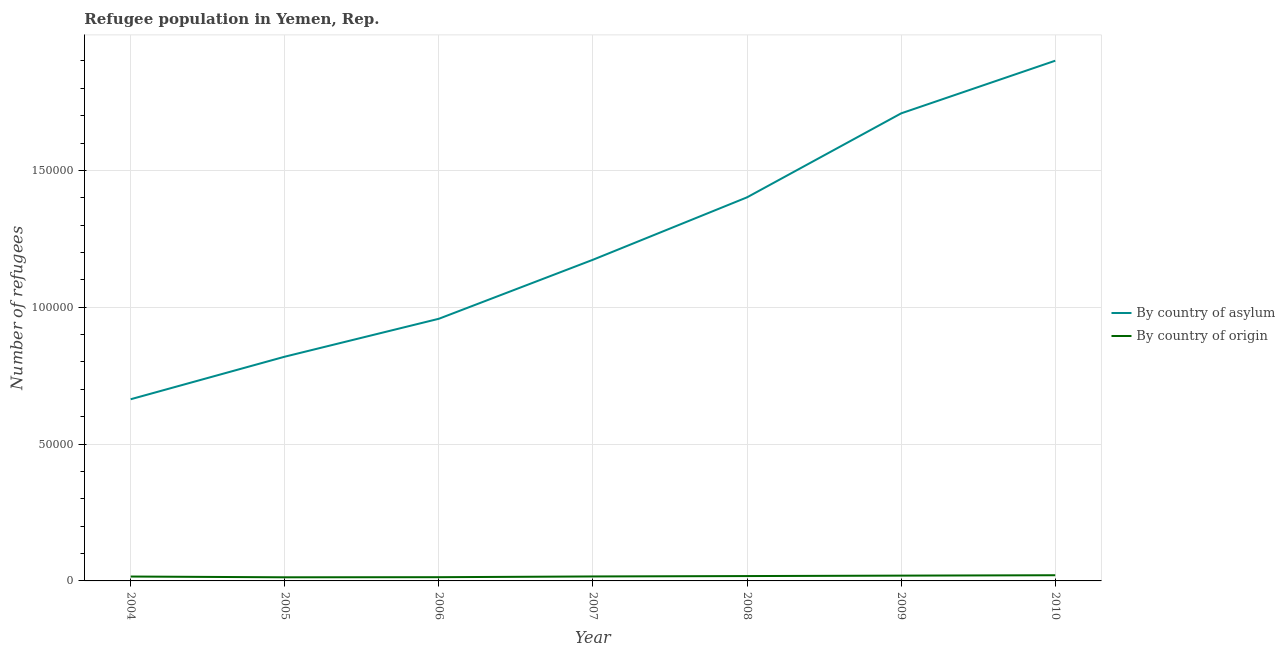Does the line corresponding to number of refugees by country of origin intersect with the line corresponding to number of refugees by country of asylum?
Make the answer very short. No. What is the number of refugees by country of origin in 2006?
Keep it short and to the point. 1362. Across all years, what is the maximum number of refugees by country of origin?
Keep it short and to the point. 2076. Across all years, what is the minimum number of refugees by country of asylum?
Your response must be concise. 6.64e+04. What is the total number of refugees by country of origin in the graph?
Ensure brevity in your answer.  1.17e+04. What is the difference between the number of refugees by country of asylum in 2004 and that in 2005?
Your answer should be very brief. -1.56e+04. What is the difference between the number of refugees by country of asylum in 2004 and the number of refugees by country of origin in 2007?
Offer a very short reply. 6.48e+04. What is the average number of refugees by country of asylum per year?
Your response must be concise. 1.23e+05. In the year 2005, what is the difference between the number of refugees by country of origin and number of refugees by country of asylum?
Give a very brief answer. -8.06e+04. What is the ratio of the number of refugees by country of origin in 2007 to that in 2010?
Give a very brief answer. 0.79. What is the difference between the highest and the second highest number of refugees by country of origin?
Offer a very short reply. 142. What is the difference between the highest and the lowest number of refugees by country of asylum?
Your answer should be compact. 1.24e+05. In how many years, is the number of refugees by country of origin greater than the average number of refugees by country of origin taken over all years?
Provide a succinct answer. 3. Is the sum of the number of refugees by country of asylum in 2008 and 2009 greater than the maximum number of refugees by country of origin across all years?
Provide a short and direct response. Yes. Is the number of refugees by country of asylum strictly greater than the number of refugees by country of origin over the years?
Your response must be concise. Yes. How many years are there in the graph?
Provide a short and direct response. 7. What is the difference between two consecutive major ticks on the Y-axis?
Offer a very short reply. 5.00e+04. Are the values on the major ticks of Y-axis written in scientific E-notation?
Offer a terse response. No. Does the graph contain grids?
Make the answer very short. Yes. How are the legend labels stacked?
Offer a terse response. Vertical. What is the title of the graph?
Provide a succinct answer. Refugee population in Yemen, Rep. Does "Foreign liabilities" appear as one of the legend labels in the graph?
Give a very brief answer. No. What is the label or title of the X-axis?
Ensure brevity in your answer.  Year. What is the label or title of the Y-axis?
Offer a terse response. Number of refugees. What is the Number of refugees of By country of asylum in 2004?
Provide a short and direct response. 6.64e+04. What is the Number of refugees of By country of origin in 2004?
Provide a short and direct response. 1606. What is the Number of refugees in By country of asylum in 2005?
Make the answer very short. 8.19e+04. What is the Number of refugees of By country of origin in 2005?
Ensure brevity in your answer.  1325. What is the Number of refugees in By country of asylum in 2006?
Offer a terse response. 9.58e+04. What is the Number of refugees of By country of origin in 2006?
Provide a succinct answer. 1362. What is the Number of refugees in By country of asylum in 2007?
Provide a succinct answer. 1.17e+05. What is the Number of refugees of By country of origin in 2007?
Your response must be concise. 1632. What is the Number of refugees of By country of asylum in 2008?
Your response must be concise. 1.40e+05. What is the Number of refugees in By country of origin in 2008?
Your response must be concise. 1777. What is the Number of refugees of By country of asylum in 2009?
Your answer should be very brief. 1.71e+05. What is the Number of refugees in By country of origin in 2009?
Your response must be concise. 1934. What is the Number of refugees of By country of asylum in 2010?
Your answer should be very brief. 1.90e+05. What is the Number of refugees of By country of origin in 2010?
Your response must be concise. 2076. Across all years, what is the maximum Number of refugees in By country of asylum?
Keep it short and to the point. 1.90e+05. Across all years, what is the maximum Number of refugees in By country of origin?
Offer a terse response. 2076. Across all years, what is the minimum Number of refugees of By country of asylum?
Your response must be concise. 6.64e+04. Across all years, what is the minimum Number of refugees in By country of origin?
Provide a short and direct response. 1325. What is the total Number of refugees of By country of asylum in the graph?
Make the answer very short. 8.63e+05. What is the total Number of refugees of By country of origin in the graph?
Your answer should be compact. 1.17e+04. What is the difference between the Number of refugees of By country of asylum in 2004 and that in 2005?
Ensure brevity in your answer.  -1.56e+04. What is the difference between the Number of refugees in By country of origin in 2004 and that in 2005?
Your response must be concise. 281. What is the difference between the Number of refugees in By country of asylum in 2004 and that in 2006?
Make the answer very short. -2.94e+04. What is the difference between the Number of refugees of By country of origin in 2004 and that in 2006?
Provide a succinct answer. 244. What is the difference between the Number of refugees of By country of asylum in 2004 and that in 2007?
Keep it short and to the point. -5.10e+04. What is the difference between the Number of refugees in By country of origin in 2004 and that in 2007?
Provide a short and direct response. -26. What is the difference between the Number of refugees in By country of asylum in 2004 and that in 2008?
Your response must be concise. -7.38e+04. What is the difference between the Number of refugees in By country of origin in 2004 and that in 2008?
Your response must be concise. -171. What is the difference between the Number of refugees of By country of asylum in 2004 and that in 2009?
Ensure brevity in your answer.  -1.04e+05. What is the difference between the Number of refugees of By country of origin in 2004 and that in 2009?
Provide a short and direct response. -328. What is the difference between the Number of refugees of By country of asylum in 2004 and that in 2010?
Keep it short and to the point. -1.24e+05. What is the difference between the Number of refugees of By country of origin in 2004 and that in 2010?
Offer a very short reply. -470. What is the difference between the Number of refugees in By country of asylum in 2005 and that in 2006?
Give a very brief answer. -1.39e+04. What is the difference between the Number of refugees in By country of origin in 2005 and that in 2006?
Give a very brief answer. -37. What is the difference between the Number of refugees of By country of asylum in 2005 and that in 2007?
Your answer should be very brief. -3.54e+04. What is the difference between the Number of refugees in By country of origin in 2005 and that in 2007?
Provide a succinct answer. -307. What is the difference between the Number of refugees in By country of asylum in 2005 and that in 2008?
Your response must be concise. -5.82e+04. What is the difference between the Number of refugees in By country of origin in 2005 and that in 2008?
Keep it short and to the point. -452. What is the difference between the Number of refugees of By country of asylum in 2005 and that in 2009?
Give a very brief answer. -8.89e+04. What is the difference between the Number of refugees in By country of origin in 2005 and that in 2009?
Make the answer very short. -609. What is the difference between the Number of refugees of By country of asylum in 2005 and that in 2010?
Your answer should be compact. -1.08e+05. What is the difference between the Number of refugees of By country of origin in 2005 and that in 2010?
Your answer should be compact. -751. What is the difference between the Number of refugees in By country of asylum in 2006 and that in 2007?
Offer a very short reply. -2.16e+04. What is the difference between the Number of refugees of By country of origin in 2006 and that in 2007?
Provide a short and direct response. -270. What is the difference between the Number of refugees in By country of asylum in 2006 and that in 2008?
Keep it short and to the point. -4.44e+04. What is the difference between the Number of refugees of By country of origin in 2006 and that in 2008?
Offer a terse response. -415. What is the difference between the Number of refugees of By country of asylum in 2006 and that in 2009?
Offer a very short reply. -7.51e+04. What is the difference between the Number of refugees of By country of origin in 2006 and that in 2009?
Your answer should be very brief. -572. What is the difference between the Number of refugees in By country of asylum in 2006 and that in 2010?
Provide a succinct answer. -9.43e+04. What is the difference between the Number of refugees of By country of origin in 2006 and that in 2010?
Your response must be concise. -714. What is the difference between the Number of refugees of By country of asylum in 2007 and that in 2008?
Make the answer very short. -2.28e+04. What is the difference between the Number of refugees of By country of origin in 2007 and that in 2008?
Make the answer very short. -145. What is the difference between the Number of refugees in By country of asylum in 2007 and that in 2009?
Your answer should be compact. -5.35e+04. What is the difference between the Number of refugees of By country of origin in 2007 and that in 2009?
Offer a very short reply. -302. What is the difference between the Number of refugees of By country of asylum in 2007 and that in 2010?
Your response must be concise. -7.27e+04. What is the difference between the Number of refugees in By country of origin in 2007 and that in 2010?
Your answer should be compact. -444. What is the difference between the Number of refugees of By country of asylum in 2008 and that in 2009?
Offer a terse response. -3.07e+04. What is the difference between the Number of refugees in By country of origin in 2008 and that in 2009?
Provide a succinct answer. -157. What is the difference between the Number of refugees of By country of asylum in 2008 and that in 2010?
Make the answer very short. -4.99e+04. What is the difference between the Number of refugees of By country of origin in 2008 and that in 2010?
Keep it short and to the point. -299. What is the difference between the Number of refugees in By country of asylum in 2009 and that in 2010?
Your answer should be compact. -1.92e+04. What is the difference between the Number of refugees of By country of origin in 2009 and that in 2010?
Your answer should be compact. -142. What is the difference between the Number of refugees in By country of asylum in 2004 and the Number of refugees in By country of origin in 2005?
Ensure brevity in your answer.  6.51e+04. What is the difference between the Number of refugees of By country of asylum in 2004 and the Number of refugees of By country of origin in 2006?
Offer a very short reply. 6.50e+04. What is the difference between the Number of refugees of By country of asylum in 2004 and the Number of refugees of By country of origin in 2007?
Make the answer very short. 6.48e+04. What is the difference between the Number of refugees of By country of asylum in 2004 and the Number of refugees of By country of origin in 2008?
Provide a succinct answer. 6.46e+04. What is the difference between the Number of refugees in By country of asylum in 2004 and the Number of refugees in By country of origin in 2009?
Your answer should be compact. 6.44e+04. What is the difference between the Number of refugees in By country of asylum in 2004 and the Number of refugees in By country of origin in 2010?
Provide a short and direct response. 6.43e+04. What is the difference between the Number of refugees in By country of asylum in 2005 and the Number of refugees in By country of origin in 2006?
Give a very brief answer. 8.06e+04. What is the difference between the Number of refugees in By country of asylum in 2005 and the Number of refugees in By country of origin in 2007?
Ensure brevity in your answer.  8.03e+04. What is the difference between the Number of refugees in By country of asylum in 2005 and the Number of refugees in By country of origin in 2008?
Your answer should be very brief. 8.02e+04. What is the difference between the Number of refugees in By country of asylum in 2005 and the Number of refugees in By country of origin in 2009?
Make the answer very short. 8.00e+04. What is the difference between the Number of refugees in By country of asylum in 2005 and the Number of refugees in By country of origin in 2010?
Make the answer very short. 7.99e+04. What is the difference between the Number of refugees of By country of asylum in 2006 and the Number of refugees of By country of origin in 2007?
Keep it short and to the point. 9.42e+04. What is the difference between the Number of refugees of By country of asylum in 2006 and the Number of refugees of By country of origin in 2008?
Keep it short and to the point. 9.40e+04. What is the difference between the Number of refugees in By country of asylum in 2006 and the Number of refugees in By country of origin in 2009?
Your answer should be very brief. 9.39e+04. What is the difference between the Number of refugees in By country of asylum in 2006 and the Number of refugees in By country of origin in 2010?
Give a very brief answer. 9.37e+04. What is the difference between the Number of refugees of By country of asylum in 2007 and the Number of refugees of By country of origin in 2008?
Keep it short and to the point. 1.16e+05. What is the difference between the Number of refugees of By country of asylum in 2007 and the Number of refugees of By country of origin in 2009?
Your answer should be compact. 1.15e+05. What is the difference between the Number of refugees of By country of asylum in 2007 and the Number of refugees of By country of origin in 2010?
Keep it short and to the point. 1.15e+05. What is the difference between the Number of refugees of By country of asylum in 2008 and the Number of refugees of By country of origin in 2009?
Your response must be concise. 1.38e+05. What is the difference between the Number of refugees in By country of asylum in 2008 and the Number of refugees in By country of origin in 2010?
Ensure brevity in your answer.  1.38e+05. What is the difference between the Number of refugees of By country of asylum in 2009 and the Number of refugees of By country of origin in 2010?
Your answer should be compact. 1.69e+05. What is the average Number of refugees of By country of asylum per year?
Your response must be concise. 1.23e+05. What is the average Number of refugees of By country of origin per year?
Keep it short and to the point. 1673.14. In the year 2004, what is the difference between the Number of refugees of By country of asylum and Number of refugees of By country of origin?
Offer a terse response. 6.48e+04. In the year 2005, what is the difference between the Number of refugees in By country of asylum and Number of refugees in By country of origin?
Provide a succinct answer. 8.06e+04. In the year 2006, what is the difference between the Number of refugees of By country of asylum and Number of refugees of By country of origin?
Ensure brevity in your answer.  9.44e+04. In the year 2007, what is the difference between the Number of refugees of By country of asylum and Number of refugees of By country of origin?
Your answer should be very brief. 1.16e+05. In the year 2008, what is the difference between the Number of refugees of By country of asylum and Number of refugees of By country of origin?
Your answer should be compact. 1.38e+05. In the year 2009, what is the difference between the Number of refugees of By country of asylum and Number of refugees of By country of origin?
Provide a short and direct response. 1.69e+05. In the year 2010, what is the difference between the Number of refugees in By country of asylum and Number of refugees in By country of origin?
Your answer should be very brief. 1.88e+05. What is the ratio of the Number of refugees in By country of asylum in 2004 to that in 2005?
Offer a very short reply. 0.81. What is the ratio of the Number of refugees in By country of origin in 2004 to that in 2005?
Your answer should be compact. 1.21. What is the ratio of the Number of refugees in By country of asylum in 2004 to that in 2006?
Provide a succinct answer. 0.69. What is the ratio of the Number of refugees in By country of origin in 2004 to that in 2006?
Offer a very short reply. 1.18. What is the ratio of the Number of refugees in By country of asylum in 2004 to that in 2007?
Provide a short and direct response. 0.57. What is the ratio of the Number of refugees of By country of origin in 2004 to that in 2007?
Give a very brief answer. 0.98. What is the ratio of the Number of refugees in By country of asylum in 2004 to that in 2008?
Provide a succinct answer. 0.47. What is the ratio of the Number of refugees of By country of origin in 2004 to that in 2008?
Offer a very short reply. 0.9. What is the ratio of the Number of refugees in By country of asylum in 2004 to that in 2009?
Provide a short and direct response. 0.39. What is the ratio of the Number of refugees of By country of origin in 2004 to that in 2009?
Ensure brevity in your answer.  0.83. What is the ratio of the Number of refugees in By country of asylum in 2004 to that in 2010?
Keep it short and to the point. 0.35. What is the ratio of the Number of refugees in By country of origin in 2004 to that in 2010?
Keep it short and to the point. 0.77. What is the ratio of the Number of refugees of By country of asylum in 2005 to that in 2006?
Offer a terse response. 0.86. What is the ratio of the Number of refugees in By country of origin in 2005 to that in 2006?
Offer a terse response. 0.97. What is the ratio of the Number of refugees in By country of asylum in 2005 to that in 2007?
Provide a succinct answer. 0.7. What is the ratio of the Number of refugees in By country of origin in 2005 to that in 2007?
Keep it short and to the point. 0.81. What is the ratio of the Number of refugees in By country of asylum in 2005 to that in 2008?
Your response must be concise. 0.58. What is the ratio of the Number of refugees in By country of origin in 2005 to that in 2008?
Keep it short and to the point. 0.75. What is the ratio of the Number of refugees in By country of asylum in 2005 to that in 2009?
Provide a succinct answer. 0.48. What is the ratio of the Number of refugees in By country of origin in 2005 to that in 2009?
Give a very brief answer. 0.69. What is the ratio of the Number of refugees of By country of asylum in 2005 to that in 2010?
Provide a succinct answer. 0.43. What is the ratio of the Number of refugees of By country of origin in 2005 to that in 2010?
Offer a terse response. 0.64. What is the ratio of the Number of refugees in By country of asylum in 2006 to that in 2007?
Provide a succinct answer. 0.82. What is the ratio of the Number of refugees in By country of origin in 2006 to that in 2007?
Provide a succinct answer. 0.83. What is the ratio of the Number of refugees of By country of asylum in 2006 to that in 2008?
Ensure brevity in your answer.  0.68. What is the ratio of the Number of refugees of By country of origin in 2006 to that in 2008?
Ensure brevity in your answer.  0.77. What is the ratio of the Number of refugees in By country of asylum in 2006 to that in 2009?
Offer a terse response. 0.56. What is the ratio of the Number of refugees in By country of origin in 2006 to that in 2009?
Give a very brief answer. 0.7. What is the ratio of the Number of refugees of By country of asylum in 2006 to that in 2010?
Provide a succinct answer. 0.5. What is the ratio of the Number of refugees in By country of origin in 2006 to that in 2010?
Provide a succinct answer. 0.66. What is the ratio of the Number of refugees of By country of asylum in 2007 to that in 2008?
Give a very brief answer. 0.84. What is the ratio of the Number of refugees of By country of origin in 2007 to that in 2008?
Your answer should be compact. 0.92. What is the ratio of the Number of refugees in By country of asylum in 2007 to that in 2009?
Your answer should be very brief. 0.69. What is the ratio of the Number of refugees in By country of origin in 2007 to that in 2009?
Offer a terse response. 0.84. What is the ratio of the Number of refugees of By country of asylum in 2007 to that in 2010?
Provide a succinct answer. 0.62. What is the ratio of the Number of refugees in By country of origin in 2007 to that in 2010?
Keep it short and to the point. 0.79. What is the ratio of the Number of refugees of By country of asylum in 2008 to that in 2009?
Keep it short and to the point. 0.82. What is the ratio of the Number of refugees of By country of origin in 2008 to that in 2009?
Your response must be concise. 0.92. What is the ratio of the Number of refugees of By country of asylum in 2008 to that in 2010?
Offer a terse response. 0.74. What is the ratio of the Number of refugees of By country of origin in 2008 to that in 2010?
Provide a short and direct response. 0.86. What is the ratio of the Number of refugees in By country of asylum in 2009 to that in 2010?
Provide a short and direct response. 0.9. What is the ratio of the Number of refugees of By country of origin in 2009 to that in 2010?
Keep it short and to the point. 0.93. What is the difference between the highest and the second highest Number of refugees in By country of asylum?
Your answer should be compact. 1.92e+04. What is the difference between the highest and the second highest Number of refugees of By country of origin?
Your answer should be compact. 142. What is the difference between the highest and the lowest Number of refugees of By country of asylum?
Provide a short and direct response. 1.24e+05. What is the difference between the highest and the lowest Number of refugees of By country of origin?
Ensure brevity in your answer.  751. 